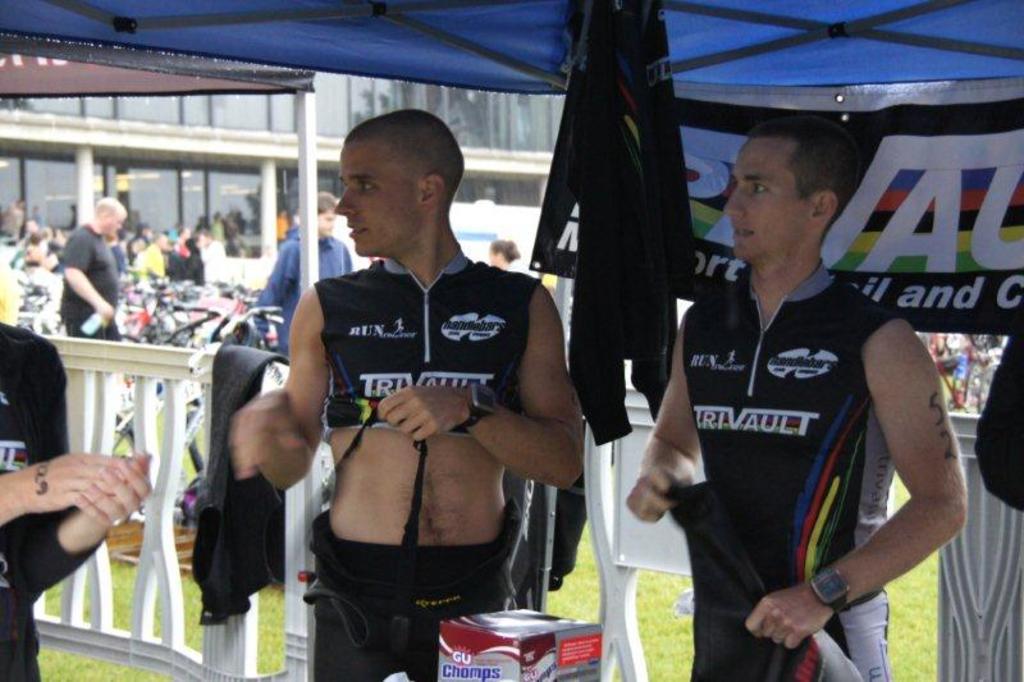What brand are the box of chomps?
Offer a very short reply. Gu. What sponsor is on the jerseys?
Offer a very short reply. Trivault. 